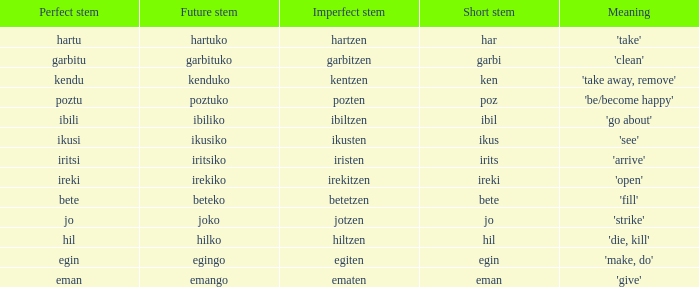Name the perfect stem for jo 1.0. 